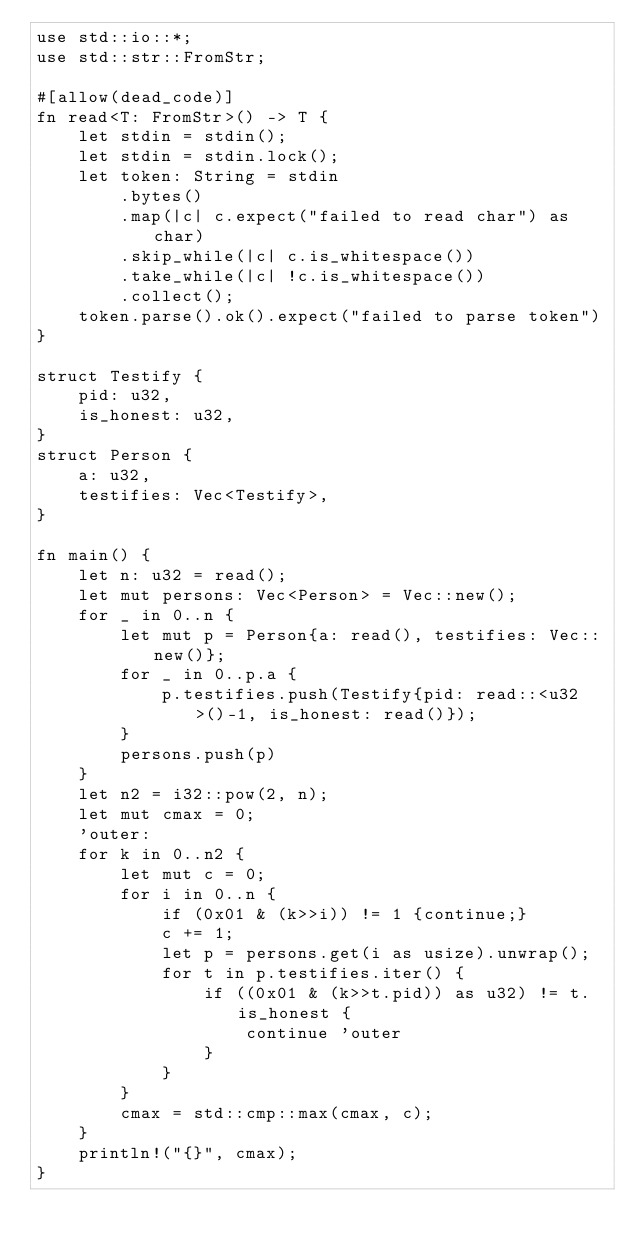<code> <loc_0><loc_0><loc_500><loc_500><_Rust_>use std::io::*;
use std::str::FromStr;

#[allow(dead_code)]
fn read<T: FromStr>() -> T {
    let stdin = stdin();
    let stdin = stdin.lock();
    let token: String = stdin
        .bytes()
        .map(|c| c.expect("failed to read char") as char) 
        .skip_while(|c| c.is_whitespace())
        .take_while(|c| !c.is_whitespace())
        .collect();
    token.parse().ok().expect("failed to parse token")
}

struct Testify {
    pid: u32,
    is_honest: u32,
}
struct Person {
    a: u32,
    testifies: Vec<Testify>,
}

fn main() {
    let n: u32 = read();
    let mut persons: Vec<Person> = Vec::new();
    for _ in 0..n {
        let mut p = Person{a: read(), testifies: Vec::new()};
        for _ in 0..p.a {
            p.testifies.push(Testify{pid: read::<u32>()-1, is_honest: read()});
        }
        persons.push(p)
    }
    let n2 = i32::pow(2, n);
    let mut cmax = 0;
    'outer:
    for k in 0..n2 {
        let mut c = 0;
        for i in 0..n {
            if (0x01 & (k>>i)) != 1 {continue;}
            c += 1;
            let p = persons.get(i as usize).unwrap();
            for t in p.testifies.iter() {
                if ((0x01 & (k>>t.pid)) as u32) != t.is_honest {
                    continue 'outer
                }
            }
        }
        cmax = std::cmp::max(cmax, c);
    }
    println!("{}", cmax);
}
</code> 